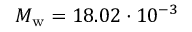<formula> <loc_0><loc_0><loc_500><loc_500>M _ { w } = 1 8 . 0 2 \cdot 1 0 ^ { - 3 }</formula> 